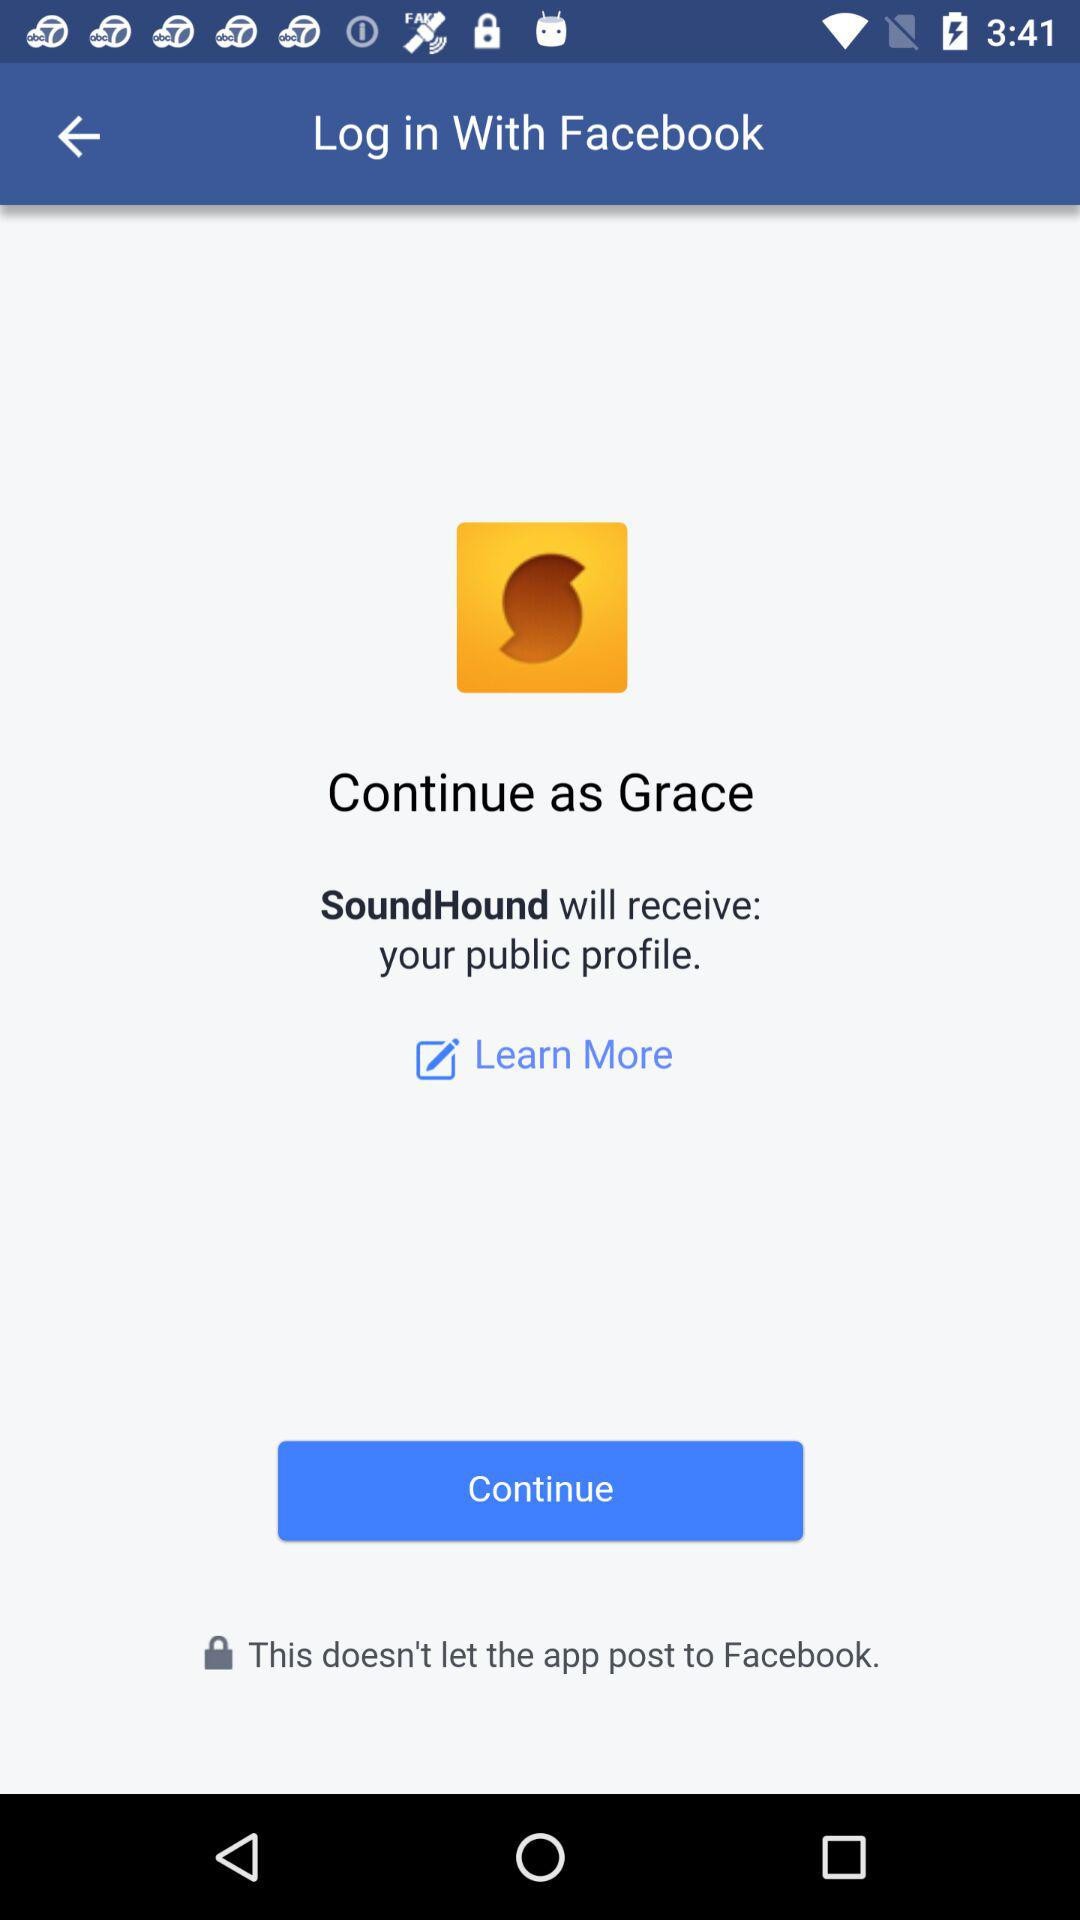What is the login name? The login name is Grace. 